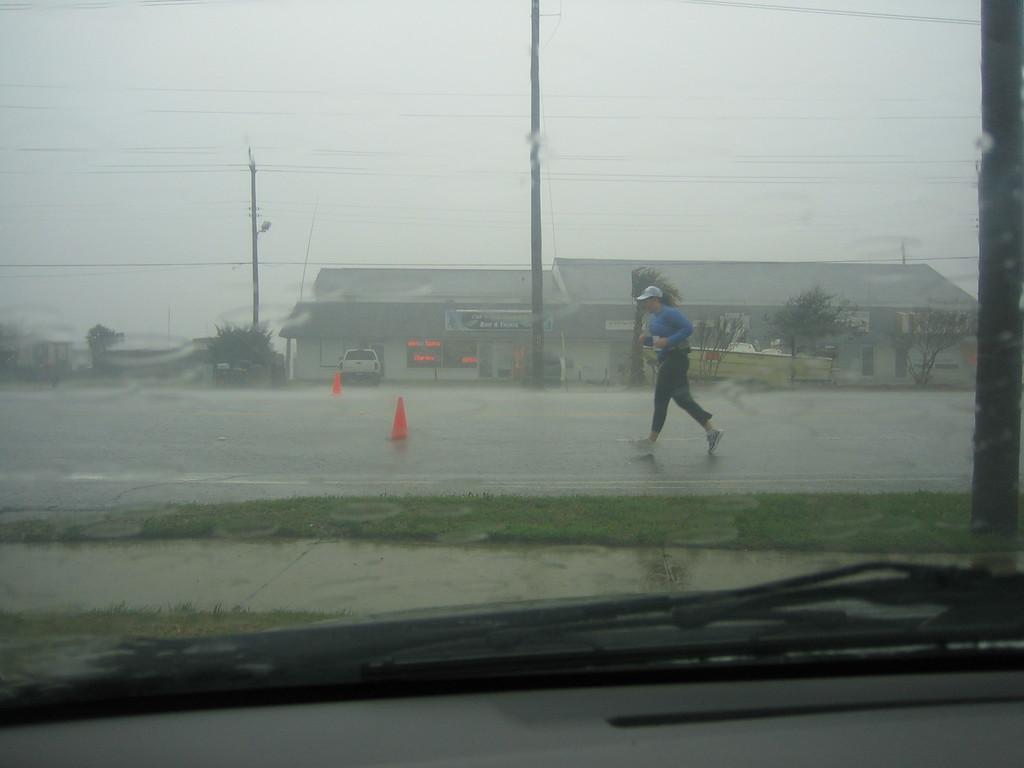Please provide a concise description of this image. There is a glass window. Through this window, we can see there is a person in blue color t-shirt running on the road on which, there are small orange color poles and water. In the background, there are poles having electric lines, a vehicle parked, trees, buildings and there is sky. 